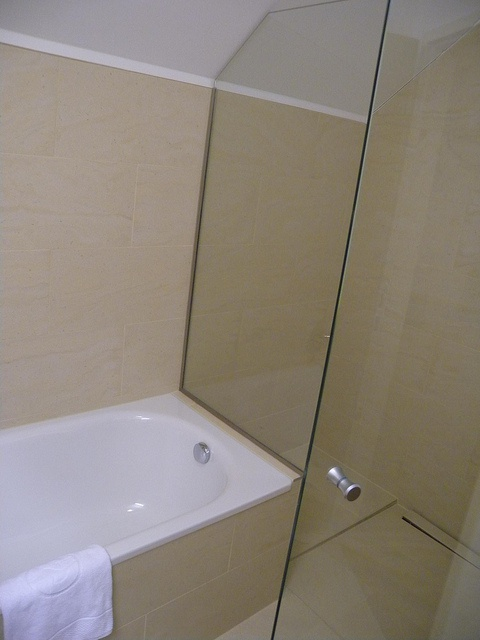Describe the objects in this image and their specific colors. I can see various objects in this image with different colors. 